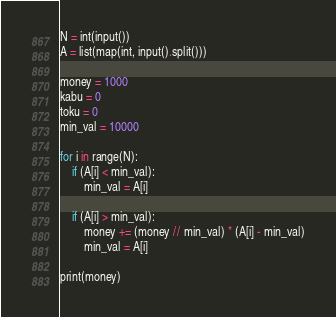<code> <loc_0><loc_0><loc_500><loc_500><_Python_>N = int(input())
A = list(map(int, input().split()))

money = 1000
kabu = 0
toku = 0
min_val = 10000

for i in range(N):
    if (A[i] < min_val):
        min_val = A[i]

    if (A[i] > min_val):
        money += (money // min_val) * (A[i] - min_val)
        min_val = A[i]

print(money)
</code> 